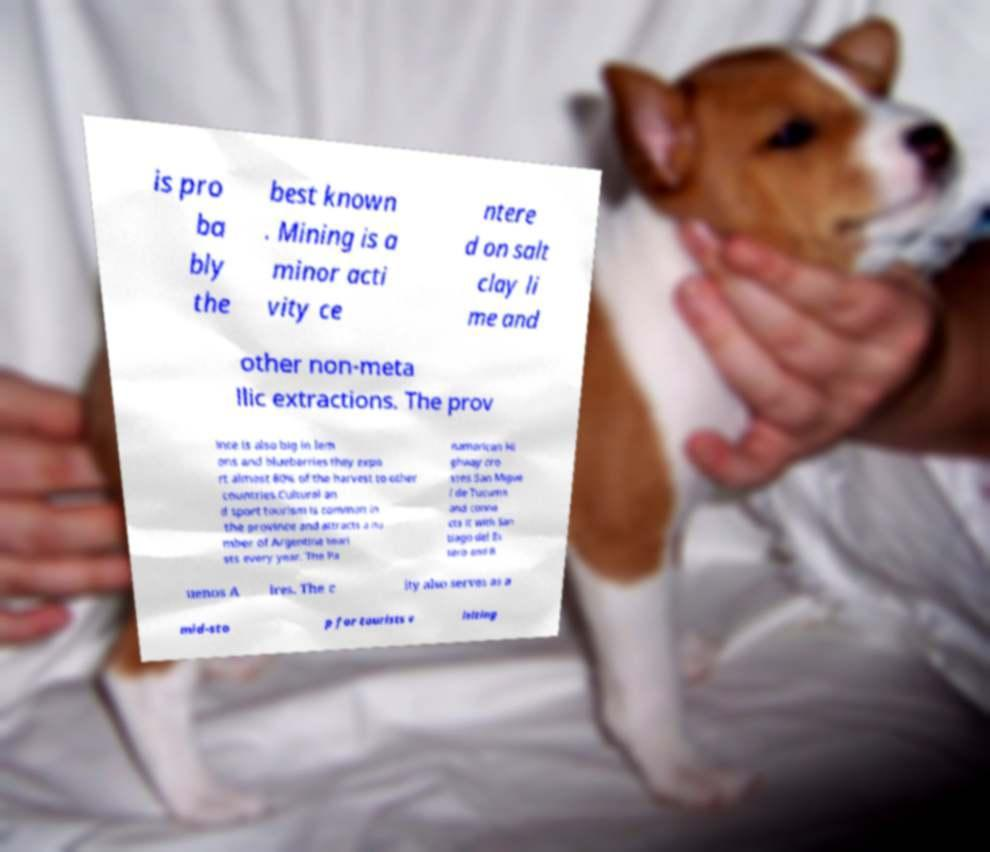Could you extract and type out the text from this image? is pro ba bly the best known . Mining is a minor acti vity ce ntere d on salt clay li me and other non-meta llic extractions. The prov ince is also big in lem ons and blueberries they expo rt almost 80% of the harvest to other countries.Cultural an d sport tourism is common in the province and attracts a nu mber of Argentine touri sts every year. The Pa namerican Hi ghway cro sses San Migue l de Tucumn and conne cts it with San tiago del Es tero and B uenos A ires. The c ity also serves as a mid-sto p for tourists v isiting 